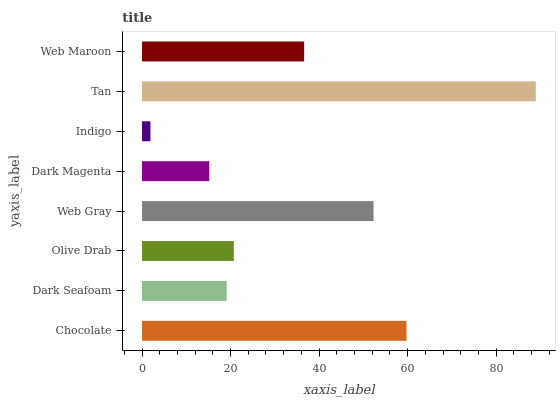Is Indigo the minimum?
Answer yes or no. Yes. Is Tan the maximum?
Answer yes or no. Yes. Is Dark Seafoam the minimum?
Answer yes or no. No. Is Dark Seafoam the maximum?
Answer yes or no. No. Is Chocolate greater than Dark Seafoam?
Answer yes or no. Yes. Is Dark Seafoam less than Chocolate?
Answer yes or no. Yes. Is Dark Seafoam greater than Chocolate?
Answer yes or no. No. Is Chocolate less than Dark Seafoam?
Answer yes or no. No. Is Web Maroon the high median?
Answer yes or no. Yes. Is Olive Drab the low median?
Answer yes or no. Yes. Is Tan the high median?
Answer yes or no. No. Is Indigo the low median?
Answer yes or no. No. 